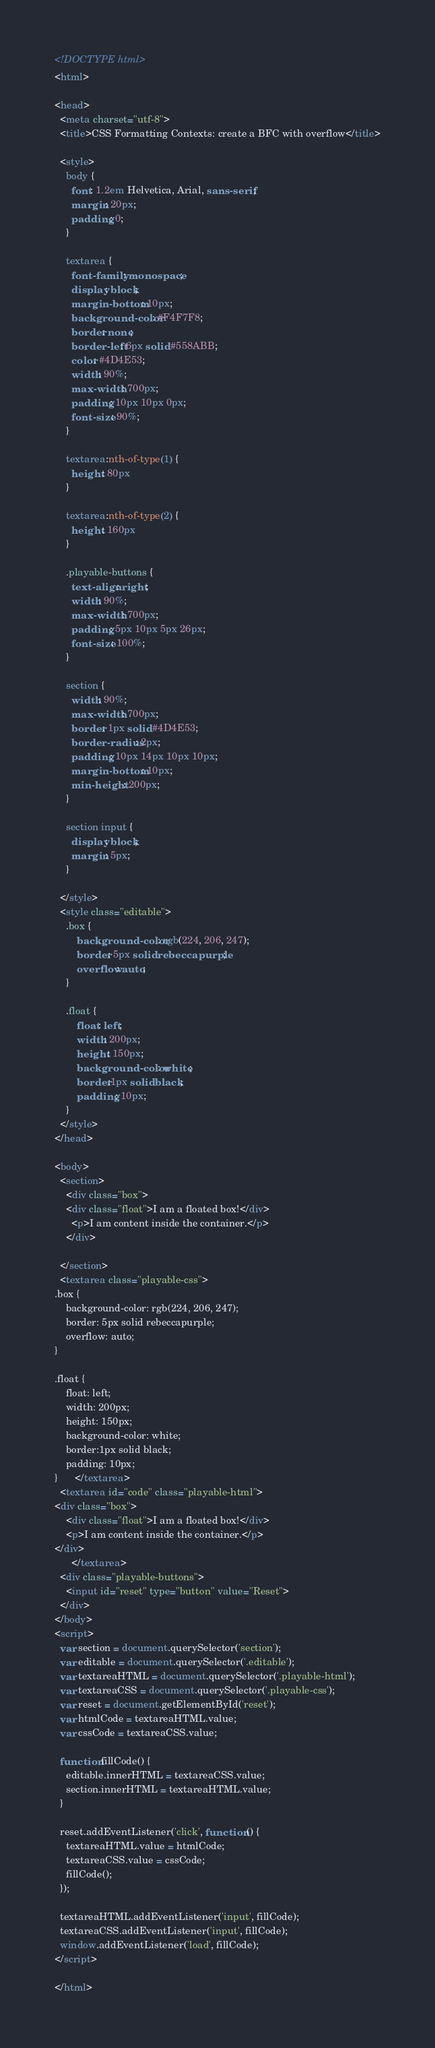<code> <loc_0><loc_0><loc_500><loc_500><_HTML_><!DOCTYPE html>
<html>

<head>
  <meta charset="utf-8">
  <title>CSS Formatting Contexts: create a BFC with overflow</title>

  <style>
    body {
      font: 1.2em Helvetica, Arial, sans-serif;
      margin: 20px;
      padding: 0;
    }

    textarea {
      font-family: monospace;
      display: block;
      margin-bottom: 10px;
      background-color: #F4F7F8;
      border: none;
      border-left: 6px solid #558ABB;
      color: #4D4E53;
      width: 90%;
      max-width: 700px;
      padding: 10px 10px 0px;
      font-size: 90%;
    }

    textarea:nth-of-type(1) {
      height: 80px
    }

    textarea:nth-of-type(2) {
      height: 160px
    }

    .playable-buttons {
      text-align: right;
      width: 90%;
      max-width: 700px;
      padding: 5px 10px 5px 26px;
      font-size: 100%;
    }

    section {
      width: 90%;
      max-width: 700px;
      border: 1px solid #4D4E53;
      border-radius: 2px;
      padding: 10px 14px 10px 10px;
      margin-bottom: 10px;
      min-height: 200px;
    }

    section input {
      display: block;
      margin: 5px;
    }

  </style>
  <style class="editable">
    .box {
        background-color: rgb(224, 206, 247);
        border: 5px solid rebeccapurple;
        overflow: auto;
    }

    .float {
        float: left;
        width: 200px;
        height: 150px;
        background-color: white;
        border:1px solid black;
        padding: 10px;
    }
  </style>
</head>

<body>
  <section>
    <div class="box">
    <div class="float">I am a floated box!</div>
      <p>I am content inside the container.</p>
    </div>

  </section>
  <textarea class="playable-css">
.box {
    background-color: rgb(224, 206, 247);
    border: 5px solid rebeccapurple;
    overflow: auto;
}

.float {
    float: left;
    width: 200px;
    height: 150px;
    background-color: white;
    border:1px solid black;
    padding: 10px;
}      </textarea>
  <textarea id="code" class="playable-html">
<div class="box">
    <div class="float">I am a floated box!</div>
    <p>I am content inside the container.</p>
</div>
      </textarea>
  <div class="playable-buttons">
    <input id="reset" type="button" value="Reset">
  </div>
</body>
<script>
  var section = document.querySelector('section');
  var editable = document.querySelector('.editable');
  var textareaHTML = document.querySelector('.playable-html');
  var textareaCSS = document.querySelector('.playable-css');
  var reset = document.getElementById('reset');
  var htmlCode = textareaHTML.value;
  var cssCode = textareaCSS.value;

  function fillCode() {
    editable.innerHTML = textareaCSS.value;
    section.innerHTML = textareaHTML.value;
  }

  reset.addEventListener('click', function () {
    textareaHTML.value = htmlCode;
    textareaCSS.value = cssCode;
    fillCode();
  });

  textareaHTML.addEventListener('input', fillCode);
  textareaCSS.addEventListener('input', fillCode);
  window.addEventListener('load', fillCode);
</script>

</html>
</code> 